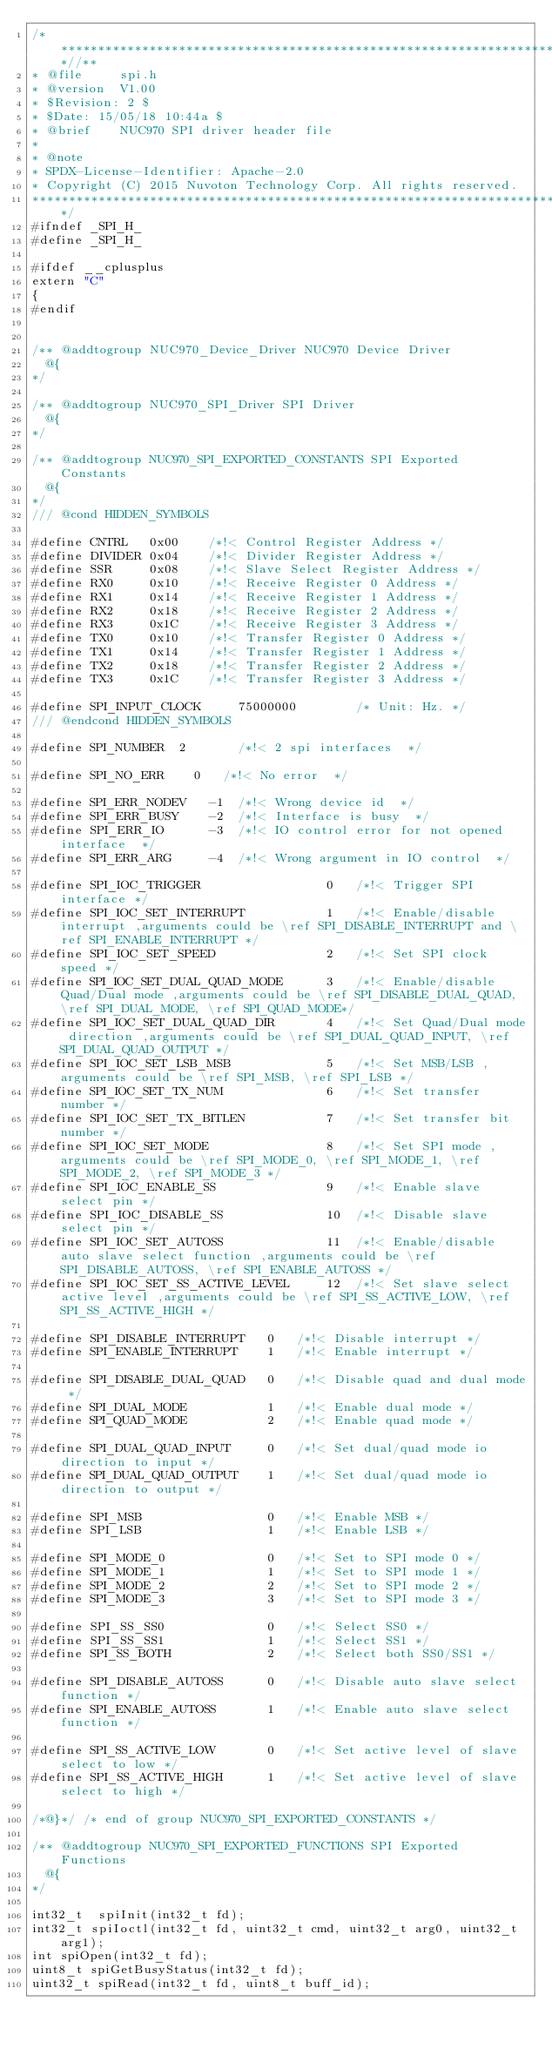<code> <loc_0><loc_0><loc_500><loc_500><_C_>/**************************************************************************//**
* @file     spi.h
* @version  V1.00
* $Revision: 2 $
* $Date: 15/05/18 10:44a $
* @brief    NUC970 SPI driver header file
*
* @note
* SPDX-License-Identifier: Apache-2.0
* Copyright (C) 2015 Nuvoton Technology Corp. All rights reserved.
*****************************************************************************/
#ifndef _SPI_H_
#define _SPI_H_

#ifdef __cplusplus
extern "C"
{
#endif


/** @addtogroup NUC970_Device_Driver NUC970 Device Driver
  @{
*/

/** @addtogroup NUC970_SPI_Driver SPI Driver
  @{
*/

/** @addtogroup NUC970_SPI_EXPORTED_CONSTANTS SPI Exported Constants
  @{
*/
/// @cond HIDDEN_SYMBOLS

#define CNTRL   0x00    /*!< Control Register Address */
#define DIVIDER 0x04    /*!< Divider Register Address */
#define SSR     0x08    /*!< Slave Select Register Address */
#define RX0     0x10    /*!< Receive Register 0 Address */
#define RX1     0x14    /*!< Receive Register 1 Address */
#define RX2     0x18    /*!< Receive Register 2 Address */
#define RX3     0x1C    /*!< Receive Register 3 Address */
#define TX0     0x10    /*!< Transfer Register 0 Address */
#define TX1     0x14    /*!< Transfer Register 1 Address */
#define TX2     0x18    /*!< Transfer Register 2 Address */
#define TX3     0x1C    /*!< Transfer Register 3 Address */

#define SPI_INPUT_CLOCK			75000000        /* Unit: Hz. */
/// @endcond HIDDEN_SYMBOLS

#define SPI_NUMBER  2       /*!< 2 spi interfaces  */

#define SPI_NO_ERR		0   /*!< No error  */

#define SPI_ERR_NODEV   -1  /*!< Wrong device id  */
#define SPI_ERR_BUSY    -2  /*!< Interface is busy  */
#define SPI_ERR_IO      -3  /*!< IO control error for not opened interface  */
#define SPI_ERR_ARG     -4  /*!< Wrong argument in IO control  */

#define SPI_IOC_TRIGGER                 0   /*!< Trigger SPI interface */
#define SPI_IOC_SET_INTERRUPT           1   /*!< Enable/disable interrupt ,arguments could be \ref SPI_DISABLE_INTERRUPT and \ref SPI_ENABLE_INTERRUPT */
#define SPI_IOC_SET_SPEED               2   /*!< Set SPI clock speed */
#define SPI_IOC_SET_DUAL_QUAD_MODE      3   /*!< Enable/disable Quad/Dual mode ,arguments could be \ref SPI_DISABLE_DUAL_QUAD, \ref SPI_DUAL_MODE, \ref SPI_QUAD_MODE*/
#define SPI_IOC_SET_DUAL_QUAD_DIR       4   /*!< Set Quad/Dual mode direction ,arguments could be \ref SPI_DUAL_QUAD_INPUT, \ref SPI_DUAL_QUAD_OUTPUT */
#define SPI_IOC_SET_LSB_MSB             5   /*!< Set MSB/LSB ,arguments could be \ref SPI_MSB, \ref SPI_LSB */
#define SPI_IOC_SET_TX_NUM              6   /*!< Set transfer number */
#define SPI_IOC_SET_TX_BITLEN           7   /*!< Set transfer bit number */
#define SPI_IOC_SET_MODE                8   /*!< Set SPI mode ,arguments could be \ref SPI_MODE_0, \ref SPI_MODE_1, \ref SPI_MODE_2, \ref SPI_MODE_3 */
#define SPI_IOC_ENABLE_SS               9   /*!< Enable slave select pin */
#define SPI_IOC_DISABLE_SS              10  /*!< Disable slave select pin */
#define SPI_IOC_SET_AUTOSS              11  /*!< Enable/disable auto slave select function ,arguments could be \ref SPI_DISABLE_AUTOSS, \ref SPI_ENABLE_AUTOSS */
#define SPI_IOC_SET_SS_ACTIVE_LEVEL     12  /*!< Set slave select active level ,arguments could be \ref SPI_SS_ACTIVE_LOW, \ref SPI_SS_ACTIVE_HIGH */

#define SPI_DISABLE_INTERRUPT   0   /*!< Disable interrupt */
#define SPI_ENABLE_INTERRUPT    1   /*!< Enable interrupt */

#define SPI_DISABLE_DUAL_QUAD   0   /*!< Disable quad and dual mode */
#define SPI_DUAL_MODE           1   /*!< Enable dual mode */
#define SPI_QUAD_MODE           2   /*!< Enable quad mode */

#define SPI_DUAL_QUAD_INPUT     0   /*!< Set dual/quad mode io direction to input */
#define SPI_DUAL_QUAD_OUTPUT    1   /*!< Set dual/quad mode io direction to output */

#define SPI_MSB                 0   /*!< Enable MSB */
#define SPI_LSB                 1   /*!< Enable LSB */

#define SPI_MODE_0              0   /*!< Set to SPI mode 0 */
#define SPI_MODE_1              1   /*!< Set to SPI mode 1 */
#define SPI_MODE_2              2   /*!< Set to SPI mode 2 */
#define SPI_MODE_3              3   /*!< Set to SPI mode 3 */

#define SPI_SS_SS0              0   /*!< Select SS0 */
#define SPI_SS_SS1              1   /*!< Select SS1 */
#define SPI_SS_BOTH             2   /*!< Select both SS0/SS1 */

#define SPI_DISABLE_AUTOSS      0   /*!< Disable auto slave select function */
#define SPI_ENABLE_AUTOSS       1   /*!< Enable auto slave select function */

#define SPI_SS_ACTIVE_LOW       0   /*!< Set active level of slave select to low */
#define SPI_SS_ACTIVE_HIGH      1   /*!< Set active level of slave select to high */

/*@}*/ /* end of group NUC970_SPI_EXPORTED_CONSTANTS */

/** @addtogroup NUC970_SPI_EXPORTED_FUNCTIONS SPI Exported Functions
  @{
*/

int32_t  spiInit(int32_t fd);
int32_t spiIoctl(int32_t fd, uint32_t cmd, uint32_t arg0, uint32_t arg1);
int spiOpen(int32_t fd);
uint8_t spiGetBusyStatus(int32_t fd);
uint32_t spiRead(int32_t fd, uint8_t buff_id);</code> 